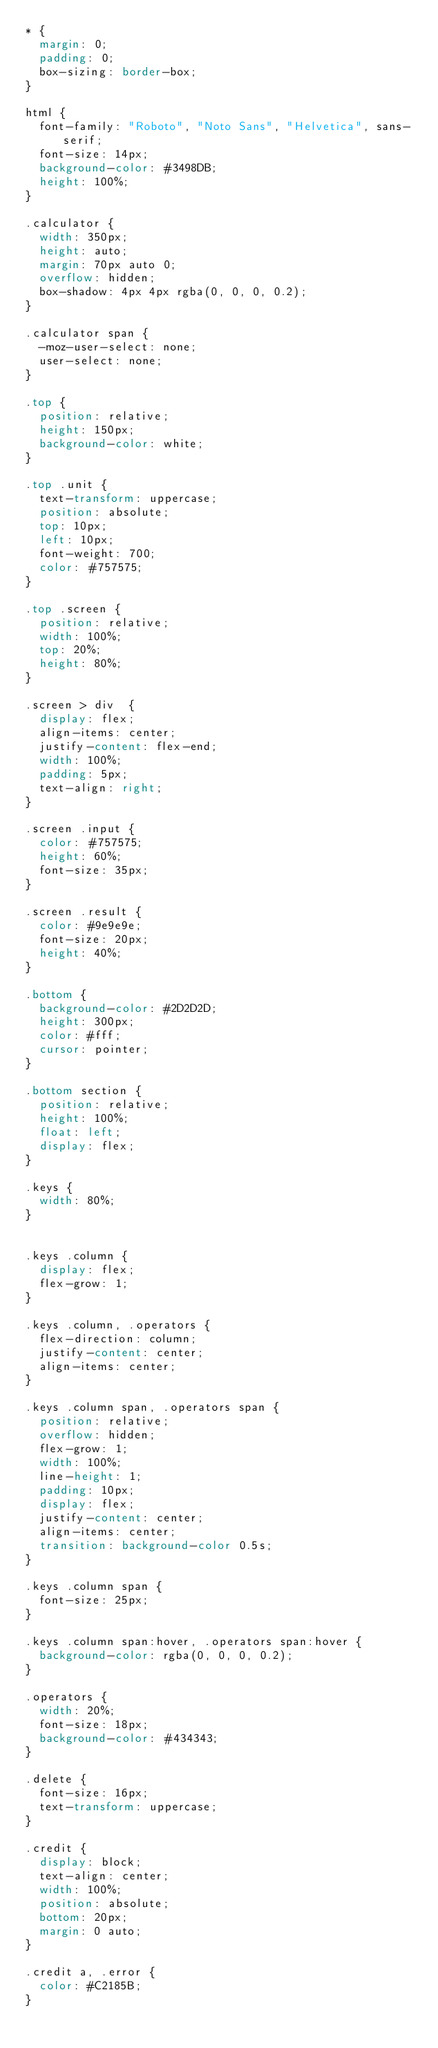<code> <loc_0><loc_0><loc_500><loc_500><_CSS_>* {
  margin: 0;
  padding: 0;
  box-sizing: border-box;
}

html {
  font-family: "Roboto", "Noto Sans", "Helvetica", sans-serif;
  font-size: 14px;
  background-color: #3498DB;
  height: 100%;
}

.calculator {
  width: 350px;
  height: auto;
  margin: 70px auto 0;
  overflow: hidden;
  box-shadow: 4px 4px rgba(0, 0, 0, 0.2);
}

.calculator span {
  -moz-user-select: none;
  user-select: none;
}

.top {
  position: relative;
  height: 150px;
  background-color: white;
}

.top .unit {
  text-transform: uppercase;
  position: absolute;
  top: 10px;
  left: 10px;
  font-weight: 700;
  color: #757575;
}

.top .screen {
  position: relative;
  width: 100%;
  top: 20%;
  height: 80%;
}

.screen > div  {
  display: flex;
  align-items: center;
  justify-content: flex-end;
  width: 100%;
  padding: 5px;
  text-align: right;
}

.screen .input {
  color: #757575;
  height: 60%;
  font-size: 35px;
}

.screen .result {
  color: #9e9e9e;
  font-size: 20px;
  height: 40%;
}

.bottom {
  background-color: #2D2D2D;
  height: 300px;
  color: #fff;
  cursor: pointer;
}

.bottom section {
  position: relative;
  height: 100%;
  float: left;
  display: flex;
}

.keys {
  width: 80%;
}


.keys .column {
  display: flex;
  flex-grow: 1;
}

.keys .column, .operators {
  flex-direction: column;
  justify-content: center;
  align-items: center;
}

.keys .column span, .operators span {
  position: relative;
  overflow: hidden;
  flex-grow: 1;
  width: 100%;
  line-height: 1;
  padding: 10px;
  display: flex;
  justify-content: center;
  align-items: center;
  transition: background-color 0.5s;
}

.keys .column span {
  font-size: 25px;
}

.keys .column span:hover, .operators span:hover {
  background-color: rgba(0, 0, 0, 0.2);
}

.operators {
  width: 20%;
  font-size: 18px;
  background-color: #434343;
}

.delete {
  font-size: 16px;
  text-transform: uppercase;
}

.credit {
  display: block;
  text-align: center;
  width: 100%;
  position: absolute;
  bottom: 20px;
  margin: 0 auto;
}

.credit a, .error {
  color: #C2185B;
}</code> 